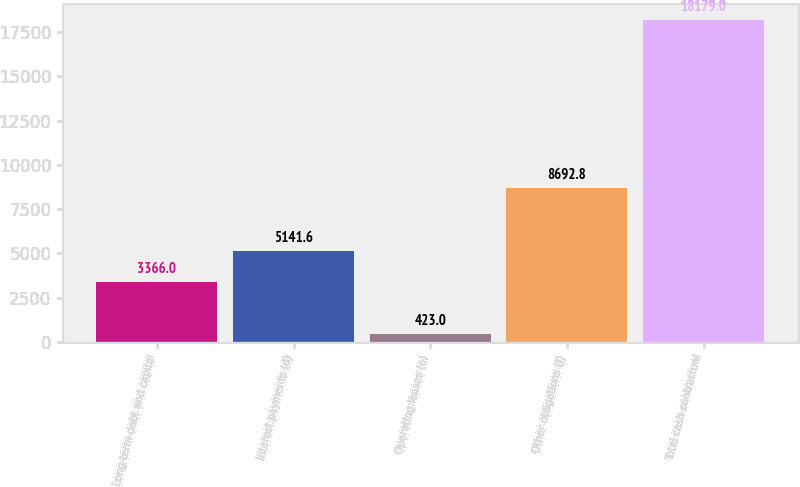<chart> <loc_0><loc_0><loc_500><loc_500><bar_chart><fcel>Long-term debt and capital<fcel>Interest payments (d)<fcel>Operating leases (e)<fcel>Other obligations (f)<fcel>Total cash contractual<nl><fcel>3366<fcel>5141.6<fcel>423<fcel>8692.8<fcel>18179<nl></chart> 